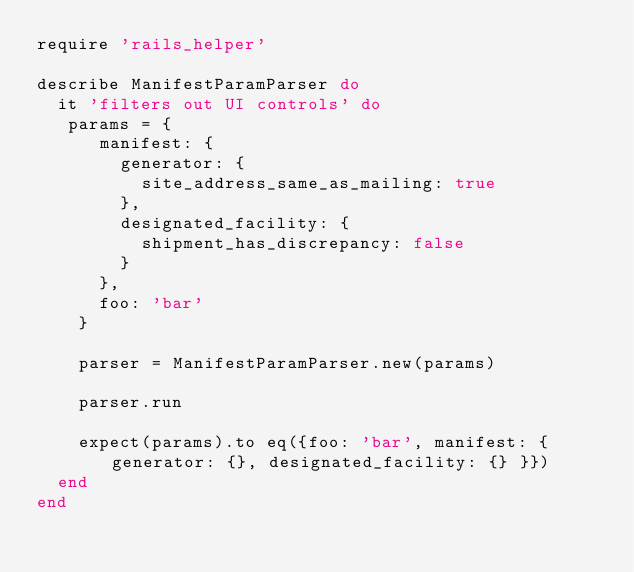Convert code to text. <code><loc_0><loc_0><loc_500><loc_500><_Ruby_>require 'rails_helper'

describe ManifestParamParser do
  it 'filters out UI controls' do
   params = { 
      manifest: { 
        generator: { 
          site_address_same_as_mailing: true 
        },
        designated_facility: {
          shipment_has_discrepancy: false
        }
      },
      foo: 'bar'
    }

    parser = ManifestParamParser.new(params)

    parser.run

    expect(params).to eq({foo: 'bar', manifest: { generator: {}, designated_facility: {} }})
  end
end
    

</code> 